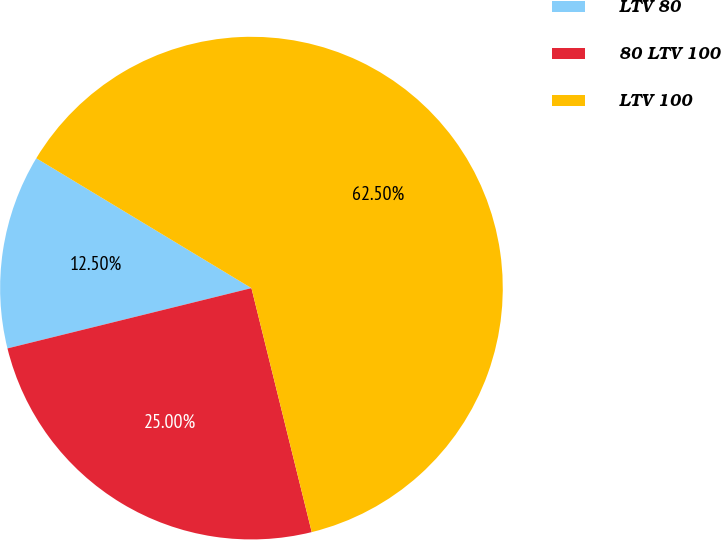<chart> <loc_0><loc_0><loc_500><loc_500><pie_chart><fcel>LTV 80<fcel>80 LTV 100<fcel>LTV 100<nl><fcel>12.5%<fcel>25.0%<fcel>62.5%<nl></chart> 